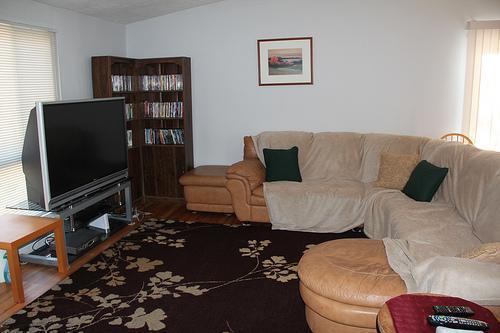How many TV's are there?
Give a very brief answer. 1. How many pillows are there?
Give a very brief answer. 4. 